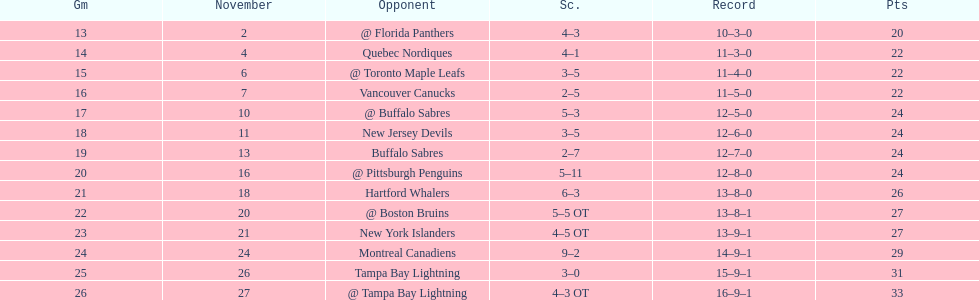Who had the most assists on the 1993-1994 flyers? Mark Recchi. 